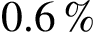<formula> <loc_0><loc_0><loc_500><loc_500>0 . 6 \, \%</formula> 